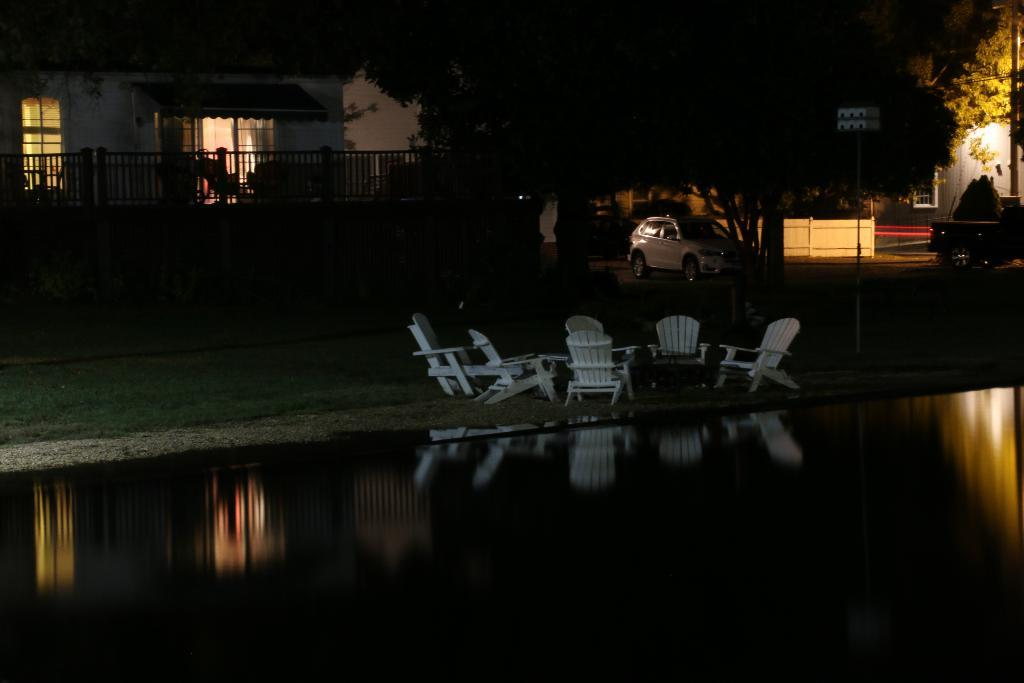What type of furniture can be seen in the image? There are chairs in the image. What natural element is visible in the image? There is water visible in the image. What type of vegetation is present in the image? There is grass in the image. What type of structure can be seen in the image? There is a house in the image. What architectural features are present in the image? There are poles, a fence, and a wall in the image. What mode of transportation is visible in the image? There is a car in the image. What type of trees are present in the image? There are trees in the image. What force is causing the zephyr to move in the image? There is no zephyr present in the image, and therefore no force is causing it to move. How many doors can be seen on the house in the image? There is no door visible on the house in the image. 